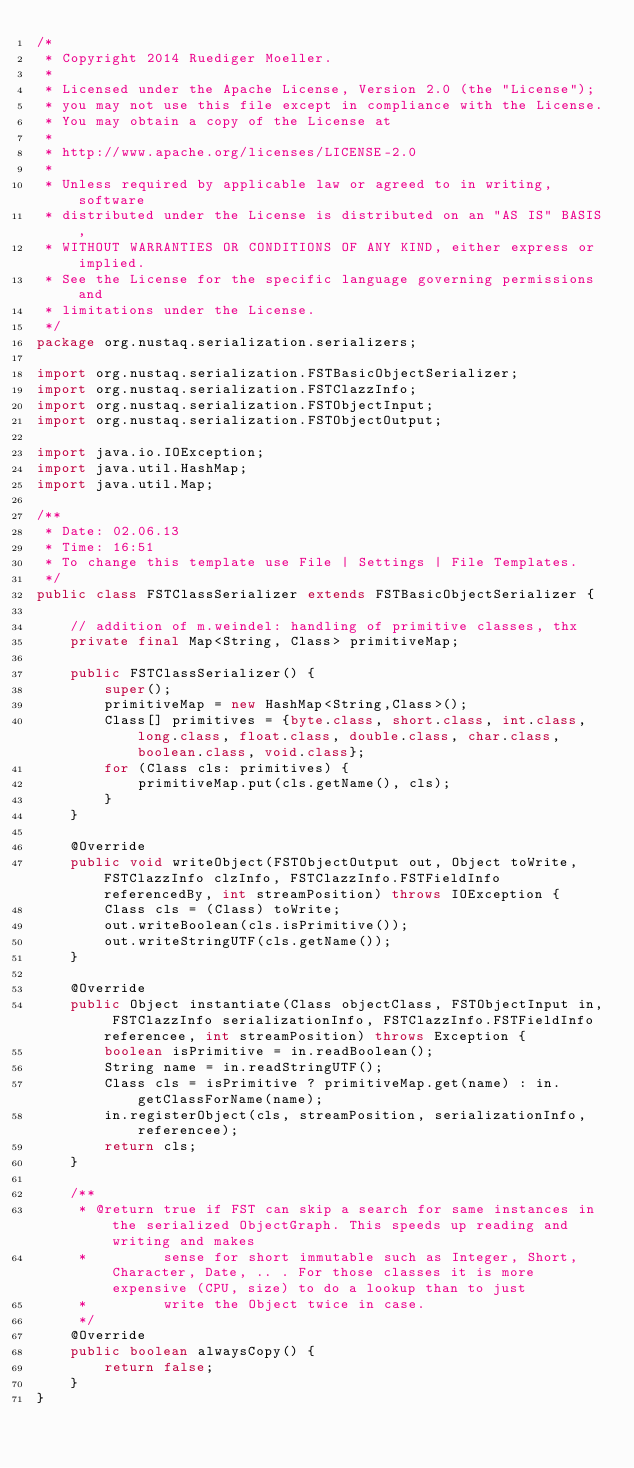<code> <loc_0><loc_0><loc_500><loc_500><_Java_>/*
 * Copyright 2014 Ruediger Moeller.
 *
 * Licensed under the Apache License, Version 2.0 (the "License");
 * you may not use this file except in compliance with the License.
 * You may obtain a copy of the License at
 *
 * http://www.apache.org/licenses/LICENSE-2.0
 *
 * Unless required by applicable law or agreed to in writing, software
 * distributed under the License is distributed on an "AS IS" BASIS,
 * WITHOUT WARRANTIES OR CONDITIONS OF ANY KIND, either express or implied.
 * See the License for the specific language governing permissions and
 * limitations under the License.
 */
package org.nustaq.serialization.serializers;

import org.nustaq.serialization.FSTBasicObjectSerializer;
import org.nustaq.serialization.FSTClazzInfo;
import org.nustaq.serialization.FSTObjectInput;
import org.nustaq.serialization.FSTObjectOutput;

import java.io.IOException;
import java.util.HashMap;
import java.util.Map;

/**
 * Date: 02.06.13
 * Time: 16:51
 * To change this template use File | Settings | File Templates.
 */
public class FSTClassSerializer extends FSTBasicObjectSerializer {

    // addition of m.weindel: handling of primitive classes, thx
    private final Map<String, Class> primitiveMap;

    public FSTClassSerializer() {
        super();
        primitiveMap = new HashMap<String,Class>();
        Class[] primitives = {byte.class, short.class, int.class, long.class, float.class, double.class, char.class, boolean.class, void.class};
        for (Class cls: primitives) {
            primitiveMap.put(cls.getName(), cls);
        }
    }

    @Override
    public void writeObject(FSTObjectOutput out, Object toWrite, FSTClazzInfo clzInfo, FSTClazzInfo.FSTFieldInfo referencedBy, int streamPosition) throws IOException {
        Class cls = (Class) toWrite;
        out.writeBoolean(cls.isPrimitive());
        out.writeStringUTF(cls.getName());
    }

    @Override
    public Object instantiate(Class objectClass, FSTObjectInput in, FSTClazzInfo serializationInfo, FSTClazzInfo.FSTFieldInfo referencee, int streamPosition) throws Exception {
        boolean isPrimitive = in.readBoolean();
        String name = in.readStringUTF();
        Class cls = isPrimitive ? primitiveMap.get(name) : in.getClassForName(name);
        in.registerObject(cls, streamPosition, serializationInfo, referencee);
        return cls;
    }

    /**
     * @return true if FST can skip a search for same instances in the serialized ObjectGraph. This speeds up reading and writing and makes
     *         sense for short immutable such as Integer, Short, Character, Date, .. . For those classes it is more expensive (CPU, size) to do a lookup than to just
     *         write the Object twice in case.
     */
    @Override
    public boolean alwaysCopy() {
        return false;
    }
}
</code> 